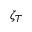Convert formula to latex. <formula><loc_0><loc_0><loc_500><loc_500>\zeta _ { T }</formula> 